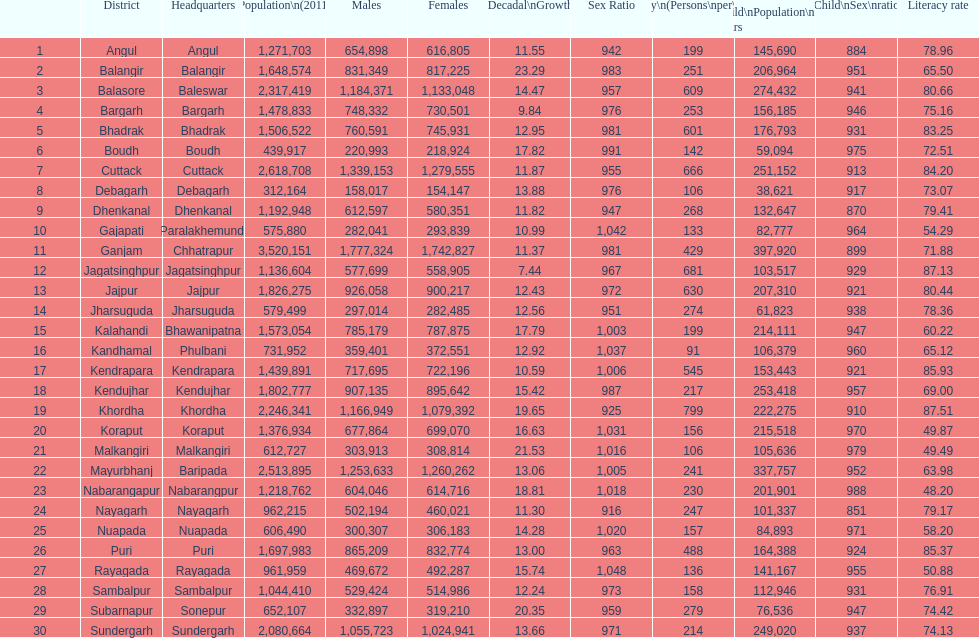Which district had the most people per km? Khordha. 